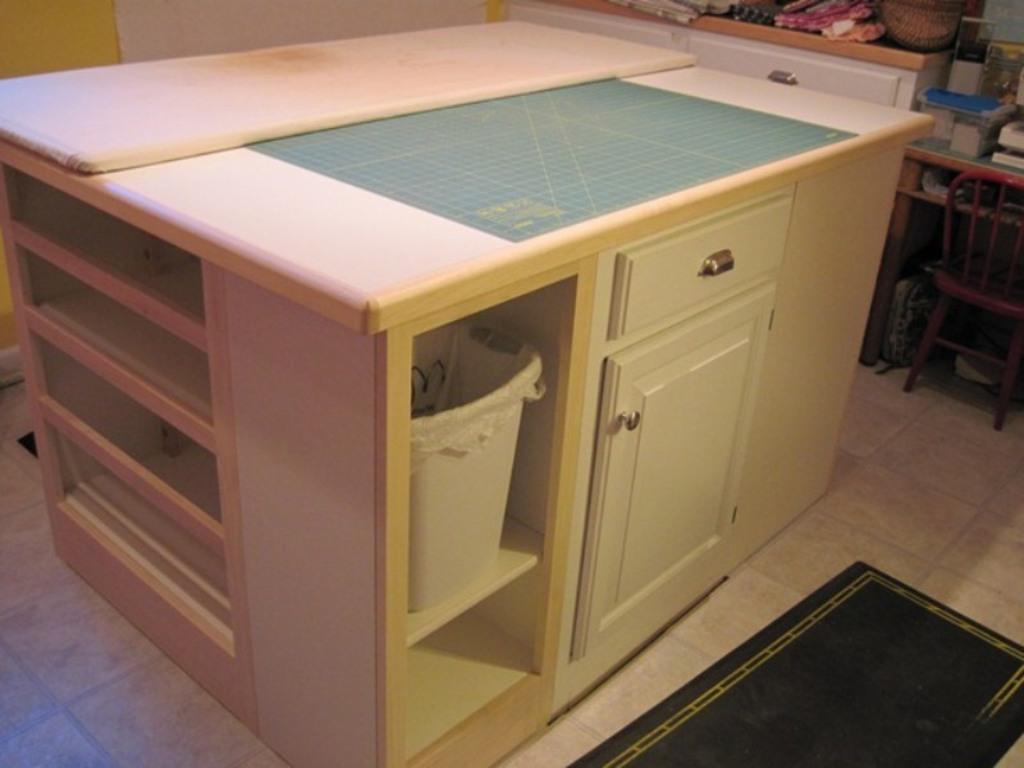In one or two sentences, can you explain what this image depicts? In this image I can see a table and the dustbin. To the right there is a chair and some of the objects on the table. 